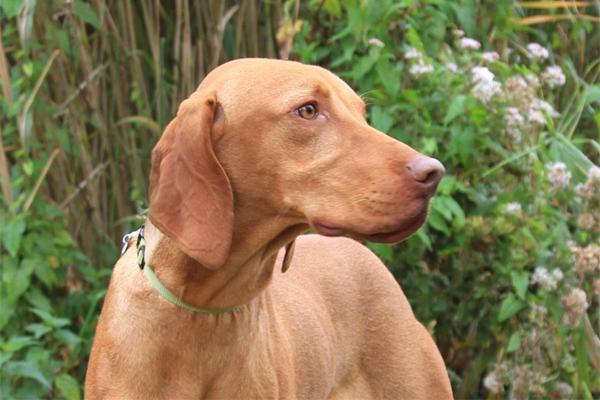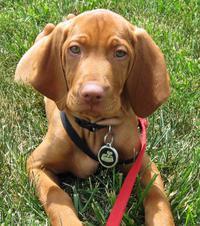The first image is the image on the left, the second image is the image on the right. For the images shown, is this caption "Both dogs are wearing collars." true? Answer yes or no. Yes. The first image is the image on the left, the second image is the image on the right. Evaluate the accuracy of this statement regarding the images: "There are two brown dogs in collars.". Is it true? Answer yes or no. Yes. 